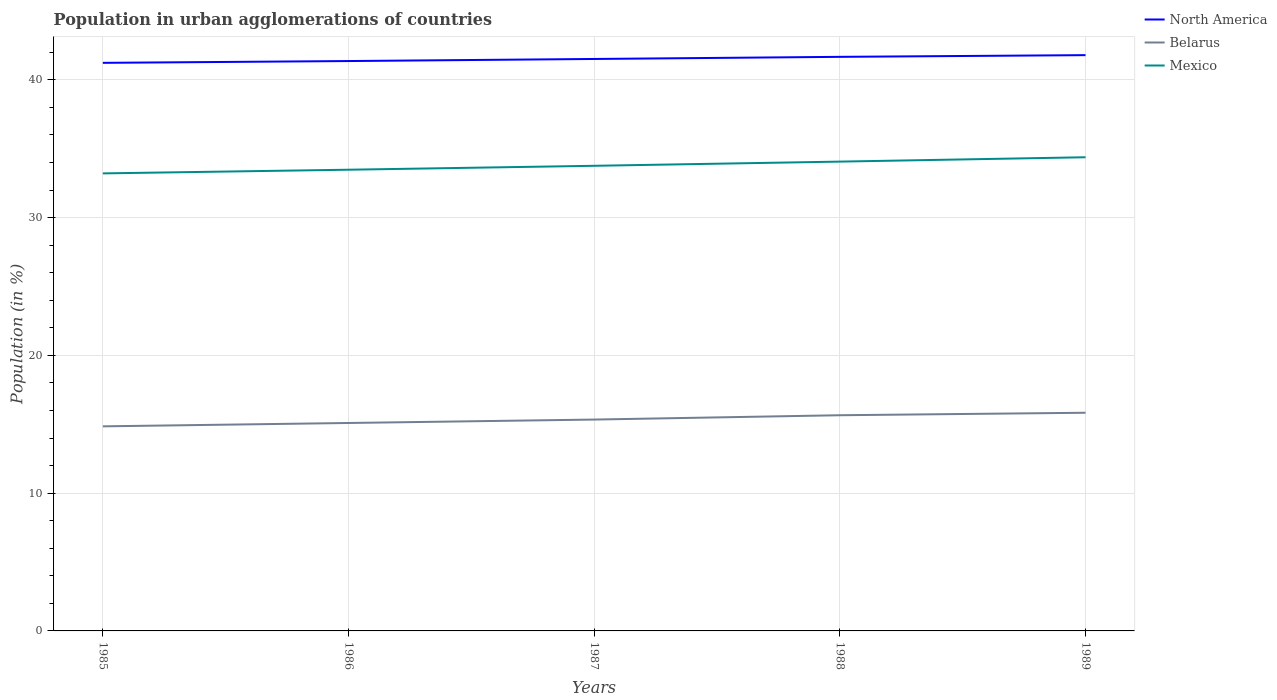How many different coloured lines are there?
Offer a terse response. 3. Is the number of lines equal to the number of legend labels?
Your response must be concise. Yes. Across all years, what is the maximum percentage of population in urban agglomerations in Belarus?
Ensure brevity in your answer.  14.85. What is the total percentage of population in urban agglomerations in Mexico in the graph?
Provide a short and direct response. -0.62. What is the difference between the highest and the second highest percentage of population in urban agglomerations in Belarus?
Your answer should be very brief. 0.99. How many lines are there?
Offer a terse response. 3. How many years are there in the graph?
Make the answer very short. 5. What is the difference between two consecutive major ticks on the Y-axis?
Offer a terse response. 10. Does the graph contain grids?
Make the answer very short. Yes. Where does the legend appear in the graph?
Provide a short and direct response. Top right. How many legend labels are there?
Make the answer very short. 3. How are the legend labels stacked?
Ensure brevity in your answer.  Vertical. What is the title of the graph?
Give a very brief answer. Population in urban agglomerations of countries. Does "Czech Republic" appear as one of the legend labels in the graph?
Your answer should be very brief. No. What is the label or title of the X-axis?
Make the answer very short. Years. What is the label or title of the Y-axis?
Your answer should be very brief. Population (in %). What is the Population (in %) in North America in 1985?
Offer a very short reply. 41.23. What is the Population (in %) in Belarus in 1985?
Your answer should be compact. 14.85. What is the Population (in %) of Mexico in 1985?
Your response must be concise. 33.21. What is the Population (in %) in North America in 1986?
Ensure brevity in your answer.  41.36. What is the Population (in %) in Belarus in 1986?
Give a very brief answer. 15.09. What is the Population (in %) in Mexico in 1986?
Your response must be concise. 33.47. What is the Population (in %) of North America in 1987?
Provide a succinct answer. 41.51. What is the Population (in %) in Belarus in 1987?
Offer a very short reply. 15.34. What is the Population (in %) in Mexico in 1987?
Keep it short and to the point. 33.76. What is the Population (in %) in North America in 1988?
Provide a succinct answer. 41.67. What is the Population (in %) of Belarus in 1988?
Ensure brevity in your answer.  15.66. What is the Population (in %) in Mexico in 1988?
Your answer should be very brief. 34.06. What is the Population (in %) of North America in 1989?
Offer a terse response. 41.79. What is the Population (in %) in Belarus in 1989?
Offer a very short reply. 15.83. What is the Population (in %) of Mexico in 1989?
Offer a terse response. 34.38. Across all years, what is the maximum Population (in %) of North America?
Provide a succinct answer. 41.79. Across all years, what is the maximum Population (in %) in Belarus?
Ensure brevity in your answer.  15.83. Across all years, what is the maximum Population (in %) of Mexico?
Your response must be concise. 34.38. Across all years, what is the minimum Population (in %) of North America?
Your response must be concise. 41.23. Across all years, what is the minimum Population (in %) of Belarus?
Ensure brevity in your answer.  14.85. Across all years, what is the minimum Population (in %) of Mexico?
Ensure brevity in your answer.  33.21. What is the total Population (in %) in North America in the graph?
Provide a short and direct response. 207.57. What is the total Population (in %) in Belarus in the graph?
Your answer should be very brief. 76.77. What is the total Population (in %) of Mexico in the graph?
Provide a succinct answer. 168.88. What is the difference between the Population (in %) in North America in 1985 and that in 1986?
Offer a very short reply. -0.13. What is the difference between the Population (in %) of Belarus in 1985 and that in 1986?
Provide a succinct answer. -0.24. What is the difference between the Population (in %) in Mexico in 1985 and that in 1986?
Ensure brevity in your answer.  -0.27. What is the difference between the Population (in %) of North America in 1985 and that in 1987?
Give a very brief answer. -0.28. What is the difference between the Population (in %) in Belarus in 1985 and that in 1987?
Make the answer very short. -0.49. What is the difference between the Population (in %) of Mexico in 1985 and that in 1987?
Your response must be concise. -0.55. What is the difference between the Population (in %) in North America in 1985 and that in 1988?
Keep it short and to the point. -0.44. What is the difference between the Population (in %) in Belarus in 1985 and that in 1988?
Give a very brief answer. -0.81. What is the difference between the Population (in %) in Mexico in 1985 and that in 1988?
Offer a terse response. -0.85. What is the difference between the Population (in %) of North America in 1985 and that in 1989?
Offer a terse response. -0.56. What is the difference between the Population (in %) of Belarus in 1985 and that in 1989?
Provide a short and direct response. -0.99. What is the difference between the Population (in %) in Mexico in 1985 and that in 1989?
Ensure brevity in your answer.  -1.17. What is the difference between the Population (in %) of North America in 1986 and that in 1987?
Make the answer very short. -0.15. What is the difference between the Population (in %) in Belarus in 1986 and that in 1987?
Your answer should be compact. -0.25. What is the difference between the Population (in %) in Mexico in 1986 and that in 1987?
Give a very brief answer. -0.29. What is the difference between the Population (in %) in North America in 1986 and that in 1988?
Your response must be concise. -0.3. What is the difference between the Population (in %) in Belarus in 1986 and that in 1988?
Give a very brief answer. -0.56. What is the difference between the Population (in %) of Mexico in 1986 and that in 1988?
Provide a short and direct response. -0.59. What is the difference between the Population (in %) in North America in 1986 and that in 1989?
Provide a succinct answer. -0.43. What is the difference between the Population (in %) of Belarus in 1986 and that in 1989?
Your response must be concise. -0.74. What is the difference between the Population (in %) in Mexico in 1986 and that in 1989?
Provide a short and direct response. -0.91. What is the difference between the Population (in %) of North America in 1987 and that in 1988?
Offer a very short reply. -0.15. What is the difference between the Population (in %) in Belarus in 1987 and that in 1988?
Ensure brevity in your answer.  -0.31. What is the difference between the Population (in %) in Mexico in 1987 and that in 1988?
Give a very brief answer. -0.3. What is the difference between the Population (in %) in North America in 1987 and that in 1989?
Provide a short and direct response. -0.28. What is the difference between the Population (in %) in Belarus in 1987 and that in 1989?
Your answer should be compact. -0.49. What is the difference between the Population (in %) in Mexico in 1987 and that in 1989?
Give a very brief answer. -0.62. What is the difference between the Population (in %) of North America in 1988 and that in 1989?
Your answer should be very brief. -0.12. What is the difference between the Population (in %) in Belarus in 1988 and that in 1989?
Your answer should be compact. -0.18. What is the difference between the Population (in %) in Mexico in 1988 and that in 1989?
Give a very brief answer. -0.32. What is the difference between the Population (in %) of North America in 1985 and the Population (in %) of Belarus in 1986?
Offer a terse response. 26.14. What is the difference between the Population (in %) of North America in 1985 and the Population (in %) of Mexico in 1986?
Offer a very short reply. 7.76. What is the difference between the Population (in %) of Belarus in 1985 and the Population (in %) of Mexico in 1986?
Make the answer very short. -18.63. What is the difference between the Population (in %) of North America in 1985 and the Population (in %) of Belarus in 1987?
Give a very brief answer. 25.89. What is the difference between the Population (in %) in North America in 1985 and the Population (in %) in Mexico in 1987?
Keep it short and to the point. 7.47. What is the difference between the Population (in %) of Belarus in 1985 and the Population (in %) of Mexico in 1987?
Ensure brevity in your answer.  -18.91. What is the difference between the Population (in %) of North America in 1985 and the Population (in %) of Belarus in 1988?
Give a very brief answer. 25.58. What is the difference between the Population (in %) of North America in 1985 and the Population (in %) of Mexico in 1988?
Your answer should be very brief. 7.17. What is the difference between the Population (in %) in Belarus in 1985 and the Population (in %) in Mexico in 1988?
Offer a very short reply. -19.21. What is the difference between the Population (in %) of North America in 1985 and the Population (in %) of Belarus in 1989?
Give a very brief answer. 25.4. What is the difference between the Population (in %) of North America in 1985 and the Population (in %) of Mexico in 1989?
Offer a terse response. 6.85. What is the difference between the Population (in %) of Belarus in 1985 and the Population (in %) of Mexico in 1989?
Provide a short and direct response. -19.53. What is the difference between the Population (in %) in North America in 1986 and the Population (in %) in Belarus in 1987?
Your answer should be very brief. 26.02. What is the difference between the Population (in %) of North America in 1986 and the Population (in %) of Mexico in 1987?
Give a very brief answer. 7.6. What is the difference between the Population (in %) in Belarus in 1986 and the Population (in %) in Mexico in 1987?
Provide a short and direct response. -18.67. What is the difference between the Population (in %) in North America in 1986 and the Population (in %) in Belarus in 1988?
Offer a very short reply. 25.71. What is the difference between the Population (in %) of North America in 1986 and the Population (in %) of Mexico in 1988?
Make the answer very short. 7.3. What is the difference between the Population (in %) of Belarus in 1986 and the Population (in %) of Mexico in 1988?
Give a very brief answer. -18.97. What is the difference between the Population (in %) in North America in 1986 and the Population (in %) in Belarus in 1989?
Your answer should be very brief. 25.53. What is the difference between the Population (in %) in North America in 1986 and the Population (in %) in Mexico in 1989?
Your response must be concise. 6.98. What is the difference between the Population (in %) of Belarus in 1986 and the Population (in %) of Mexico in 1989?
Offer a very short reply. -19.29. What is the difference between the Population (in %) of North America in 1987 and the Population (in %) of Belarus in 1988?
Offer a very short reply. 25.86. What is the difference between the Population (in %) of North America in 1987 and the Population (in %) of Mexico in 1988?
Ensure brevity in your answer.  7.45. What is the difference between the Population (in %) in Belarus in 1987 and the Population (in %) in Mexico in 1988?
Provide a short and direct response. -18.72. What is the difference between the Population (in %) of North America in 1987 and the Population (in %) of Belarus in 1989?
Give a very brief answer. 25.68. What is the difference between the Population (in %) of North America in 1987 and the Population (in %) of Mexico in 1989?
Keep it short and to the point. 7.13. What is the difference between the Population (in %) of Belarus in 1987 and the Population (in %) of Mexico in 1989?
Your response must be concise. -19.04. What is the difference between the Population (in %) in North America in 1988 and the Population (in %) in Belarus in 1989?
Provide a short and direct response. 25.83. What is the difference between the Population (in %) in North America in 1988 and the Population (in %) in Mexico in 1989?
Provide a short and direct response. 7.29. What is the difference between the Population (in %) of Belarus in 1988 and the Population (in %) of Mexico in 1989?
Give a very brief answer. -18.72. What is the average Population (in %) of North America per year?
Provide a short and direct response. 41.51. What is the average Population (in %) in Belarus per year?
Give a very brief answer. 15.35. What is the average Population (in %) in Mexico per year?
Provide a short and direct response. 33.78. In the year 1985, what is the difference between the Population (in %) in North America and Population (in %) in Belarus?
Ensure brevity in your answer.  26.38. In the year 1985, what is the difference between the Population (in %) in North America and Population (in %) in Mexico?
Provide a succinct answer. 8.02. In the year 1985, what is the difference between the Population (in %) in Belarus and Population (in %) in Mexico?
Give a very brief answer. -18.36. In the year 1986, what is the difference between the Population (in %) of North America and Population (in %) of Belarus?
Offer a very short reply. 26.27. In the year 1986, what is the difference between the Population (in %) in North America and Population (in %) in Mexico?
Ensure brevity in your answer.  7.89. In the year 1986, what is the difference between the Population (in %) of Belarus and Population (in %) of Mexico?
Give a very brief answer. -18.38. In the year 1987, what is the difference between the Population (in %) in North America and Population (in %) in Belarus?
Keep it short and to the point. 26.17. In the year 1987, what is the difference between the Population (in %) of North America and Population (in %) of Mexico?
Make the answer very short. 7.75. In the year 1987, what is the difference between the Population (in %) of Belarus and Population (in %) of Mexico?
Ensure brevity in your answer.  -18.42. In the year 1988, what is the difference between the Population (in %) in North America and Population (in %) in Belarus?
Keep it short and to the point. 26.01. In the year 1988, what is the difference between the Population (in %) of North America and Population (in %) of Mexico?
Give a very brief answer. 7.6. In the year 1988, what is the difference between the Population (in %) in Belarus and Population (in %) in Mexico?
Offer a very short reply. -18.41. In the year 1989, what is the difference between the Population (in %) in North America and Population (in %) in Belarus?
Your answer should be compact. 25.96. In the year 1989, what is the difference between the Population (in %) in North America and Population (in %) in Mexico?
Make the answer very short. 7.41. In the year 1989, what is the difference between the Population (in %) in Belarus and Population (in %) in Mexico?
Provide a succinct answer. -18.55. What is the ratio of the Population (in %) in North America in 1985 to that in 1986?
Keep it short and to the point. 1. What is the ratio of the Population (in %) in Belarus in 1985 to that in 1986?
Offer a very short reply. 0.98. What is the ratio of the Population (in %) of North America in 1985 to that in 1987?
Offer a terse response. 0.99. What is the ratio of the Population (in %) in Belarus in 1985 to that in 1987?
Your answer should be compact. 0.97. What is the ratio of the Population (in %) of Mexico in 1985 to that in 1987?
Your response must be concise. 0.98. What is the ratio of the Population (in %) of North America in 1985 to that in 1988?
Provide a short and direct response. 0.99. What is the ratio of the Population (in %) in Belarus in 1985 to that in 1988?
Your answer should be compact. 0.95. What is the ratio of the Population (in %) in Mexico in 1985 to that in 1988?
Ensure brevity in your answer.  0.97. What is the ratio of the Population (in %) in North America in 1985 to that in 1989?
Offer a terse response. 0.99. What is the ratio of the Population (in %) in Belarus in 1985 to that in 1989?
Your response must be concise. 0.94. What is the ratio of the Population (in %) of Mexico in 1985 to that in 1989?
Your response must be concise. 0.97. What is the ratio of the Population (in %) of Belarus in 1986 to that in 1987?
Make the answer very short. 0.98. What is the ratio of the Population (in %) of North America in 1986 to that in 1988?
Offer a terse response. 0.99. What is the ratio of the Population (in %) in Belarus in 1986 to that in 1988?
Give a very brief answer. 0.96. What is the ratio of the Population (in %) of Mexico in 1986 to that in 1988?
Your response must be concise. 0.98. What is the ratio of the Population (in %) in Belarus in 1986 to that in 1989?
Provide a succinct answer. 0.95. What is the ratio of the Population (in %) of Mexico in 1986 to that in 1989?
Keep it short and to the point. 0.97. What is the ratio of the Population (in %) of North America in 1987 to that in 1988?
Your answer should be compact. 1. What is the ratio of the Population (in %) of Belarus in 1987 to that in 1988?
Make the answer very short. 0.98. What is the ratio of the Population (in %) in Mexico in 1987 to that in 1988?
Give a very brief answer. 0.99. What is the ratio of the Population (in %) of Belarus in 1987 to that in 1989?
Offer a terse response. 0.97. What is the ratio of the Population (in %) in Mexico in 1987 to that in 1989?
Your answer should be very brief. 0.98. What is the ratio of the Population (in %) in North America in 1988 to that in 1989?
Provide a succinct answer. 1. What is the ratio of the Population (in %) in Belarus in 1988 to that in 1989?
Ensure brevity in your answer.  0.99. What is the ratio of the Population (in %) of Mexico in 1988 to that in 1989?
Your answer should be very brief. 0.99. What is the difference between the highest and the second highest Population (in %) in North America?
Offer a terse response. 0.12. What is the difference between the highest and the second highest Population (in %) in Belarus?
Keep it short and to the point. 0.18. What is the difference between the highest and the second highest Population (in %) of Mexico?
Provide a short and direct response. 0.32. What is the difference between the highest and the lowest Population (in %) of North America?
Make the answer very short. 0.56. What is the difference between the highest and the lowest Population (in %) in Belarus?
Make the answer very short. 0.99. What is the difference between the highest and the lowest Population (in %) of Mexico?
Your answer should be compact. 1.17. 